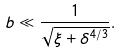<formula> <loc_0><loc_0><loc_500><loc_500>b \ll \frac { 1 } { \sqrt { \xi + \delta ^ { 4 / 3 } } } .</formula> 